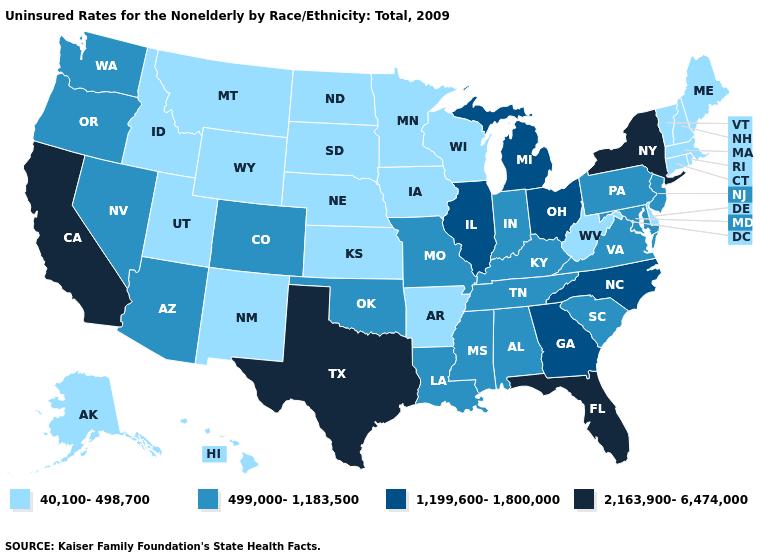What is the highest value in states that border Montana?
Give a very brief answer. 40,100-498,700. What is the value of Montana?
Be succinct. 40,100-498,700. Name the states that have a value in the range 1,199,600-1,800,000?
Answer briefly. Georgia, Illinois, Michigan, North Carolina, Ohio. What is the highest value in states that border New York?
Be succinct. 499,000-1,183,500. What is the highest value in states that border Mississippi?
Be succinct. 499,000-1,183,500. What is the highest value in states that border Utah?
Be succinct. 499,000-1,183,500. Name the states that have a value in the range 2,163,900-6,474,000?
Short answer required. California, Florida, New York, Texas. What is the highest value in the Northeast ?
Quick response, please. 2,163,900-6,474,000. Name the states that have a value in the range 499,000-1,183,500?
Quick response, please. Alabama, Arizona, Colorado, Indiana, Kentucky, Louisiana, Maryland, Mississippi, Missouri, Nevada, New Jersey, Oklahoma, Oregon, Pennsylvania, South Carolina, Tennessee, Virginia, Washington. What is the value of New Jersey?
Keep it brief. 499,000-1,183,500. Does the first symbol in the legend represent the smallest category?
Write a very short answer. Yes. Name the states that have a value in the range 1,199,600-1,800,000?
Keep it brief. Georgia, Illinois, Michigan, North Carolina, Ohio. Which states have the lowest value in the USA?
Quick response, please. Alaska, Arkansas, Connecticut, Delaware, Hawaii, Idaho, Iowa, Kansas, Maine, Massachusetts, Minnesota, Montana, Nebraska, New Hampshire, New Mexico, North Dakota, Rhode Island, South Dakota, Utah, Vermont, West Virginia, Wisconsin, Wyoming. Among the states that border Virginia , does West Virginia have the lowest value?
Write a very short answer. Yes. Does North Dakota have a higher value than Pennsylvania?
Keep it brief. No. 